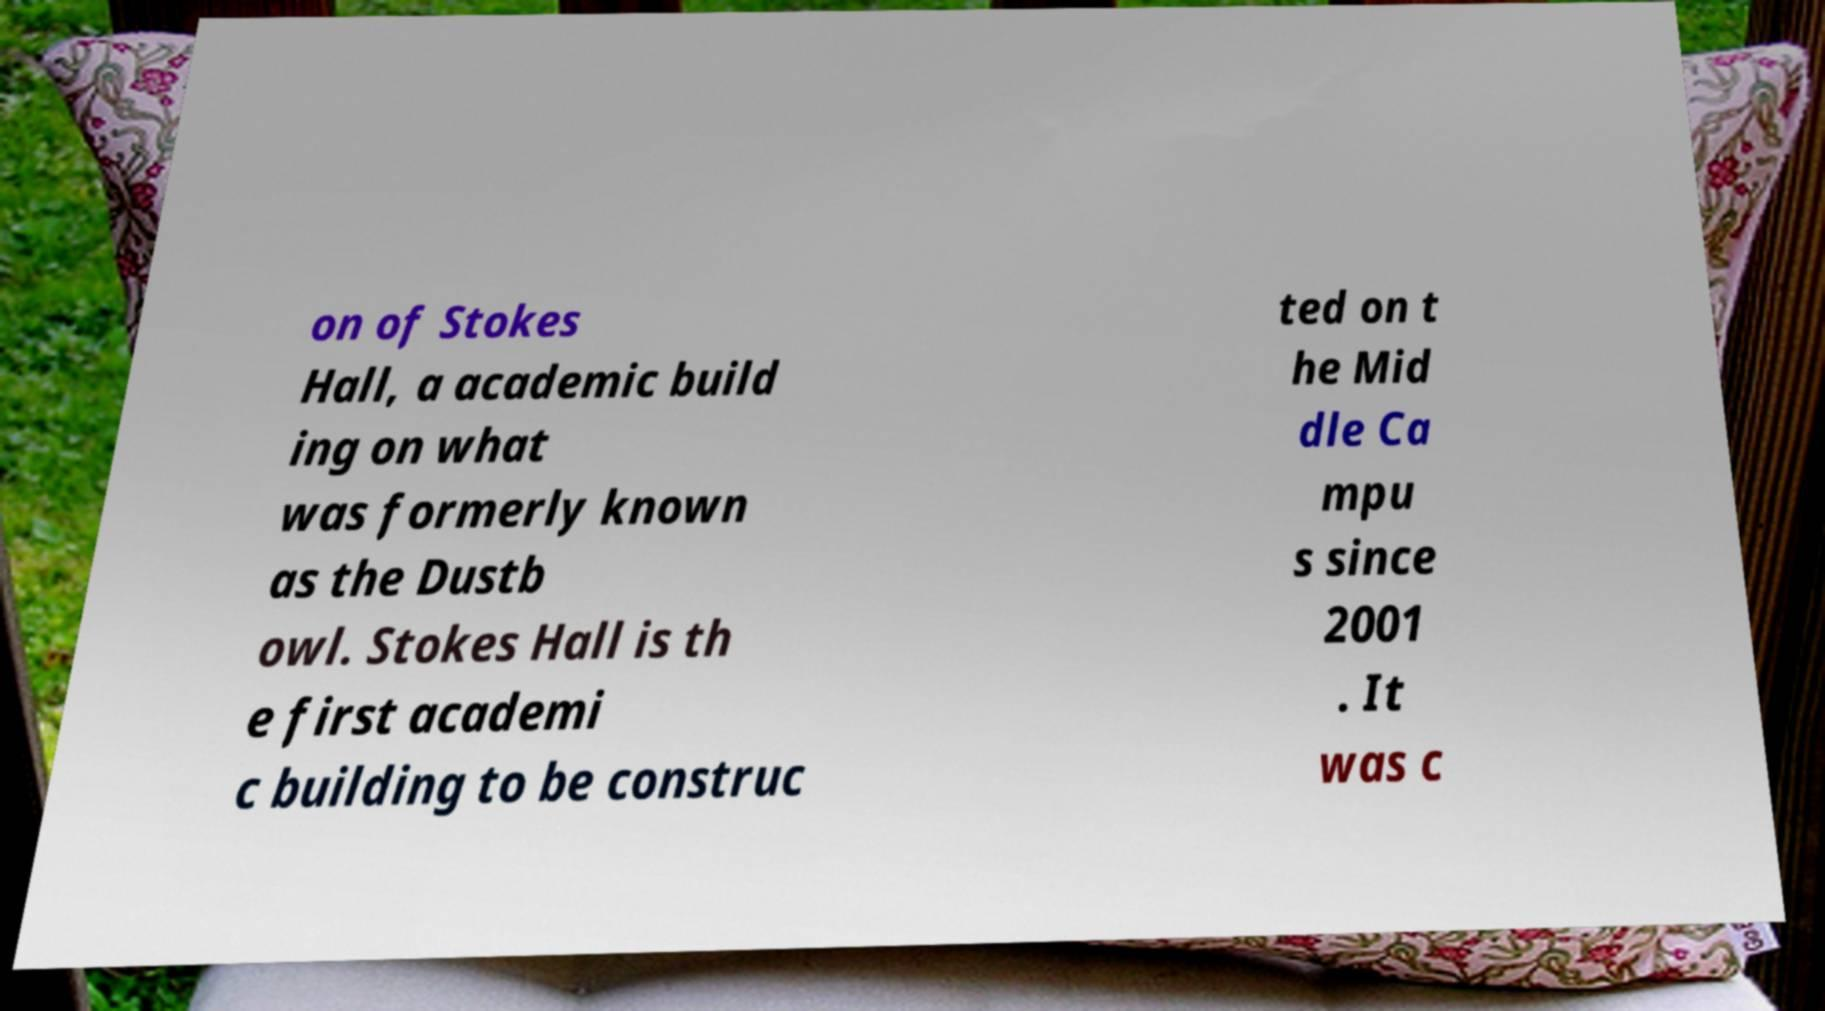Can you accurately transcribe the text from the provided image for me? on of Stokes Hall, a academic build ing on what was formerly known as the Dustb owl. Stokes Hall is th e first academi c building to be construc ted on t he Mid dle Ca mpu s since 2001 . It was c 